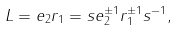Convert formula to latex. <formula><loc_0><loc_0><loc_500><loc_500>L = e _ { 2 } r _ { 1 } = s e _ { 2 } ^ { \pm 1 } r _ { 1 } ^ { \pm 1 } s ^ { - 1 } ,</formula> 